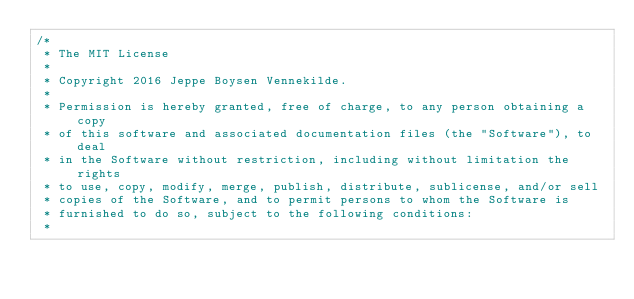<code> <loc_0><loc_0><loc_500><loc_500><_SQL_>/* 
 * The MIT License
 *
 * Copyright 2016 Jeppe Boysen Vennekilde.
 *
 * Permission is hereby granted, free of charge, to any person obtaining a copy
 * of this software and associated documentation files (the "Software"), to deal
 * in the Software without restriction, including without limitation the rights
 * to use, copy, modify, merge, publish, distribute, sublicense, and/or sell
 * copies of the Software, and to permit persons to whom the Software is
 * furnished to do so, subject to the following conditions:
 *</code> 